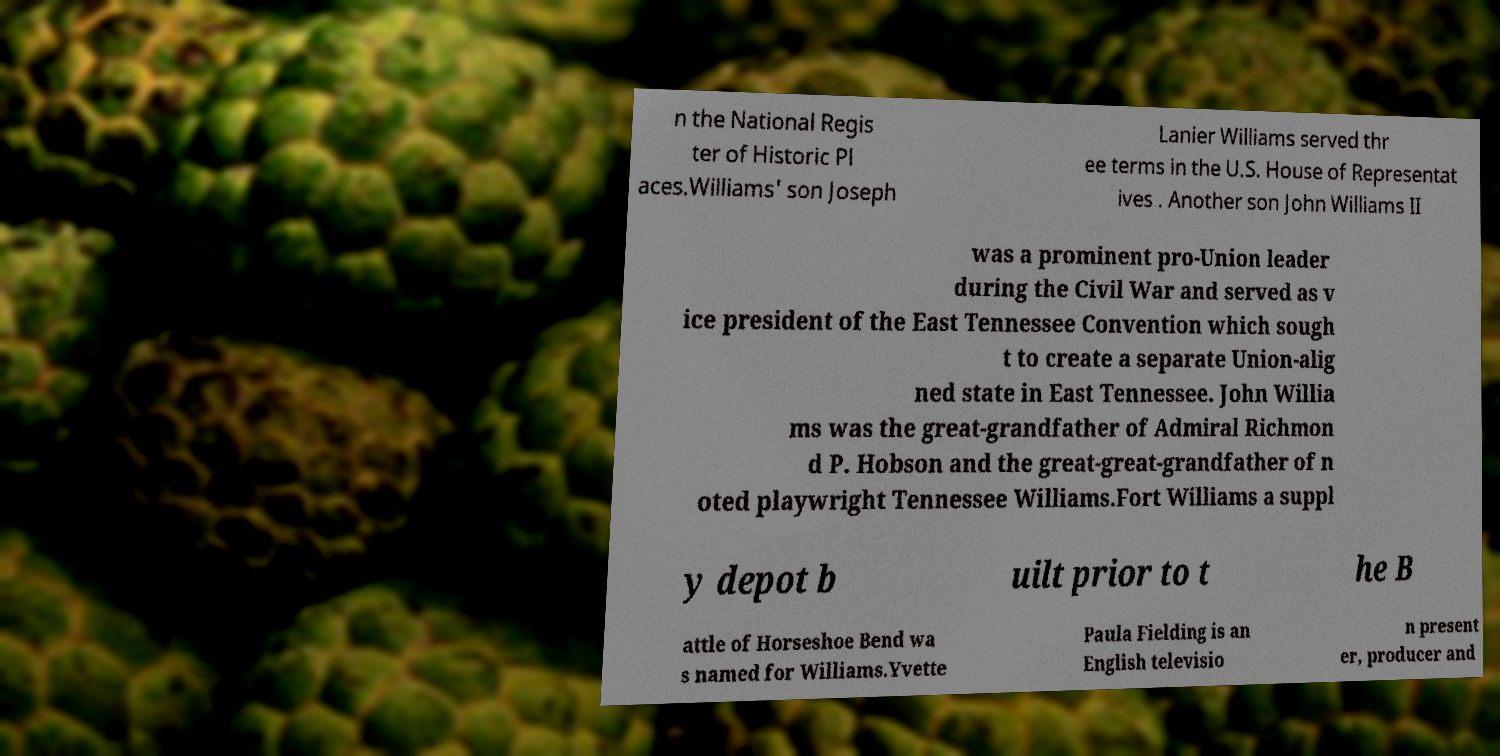What messages or text are displayed in this image? I need them in a readable, typed format. n the National Regis ter of Historic Pl aces.Williams' son Joseph Lanier Williams served thr ee terms in the U.S. House of Representat ives . Another son John Williams II was a prominent pro-Union leader during the Civil War and served as v ice president of the East Tennessee Convention which sough t to create a separate Union-alig ned state in East Tennessee. John Willia ms was the great-grandfather of Admiral Richmon d P. Hobson and the great-great-grandfather of n oted playwright Tennessee Williams.Fort Williams a suppl y depot b uilt prior to t he B attle of Horseshoe Bend wa s named for Williams.Yvette Paula Fielding is an English televisio n present er, producer and 